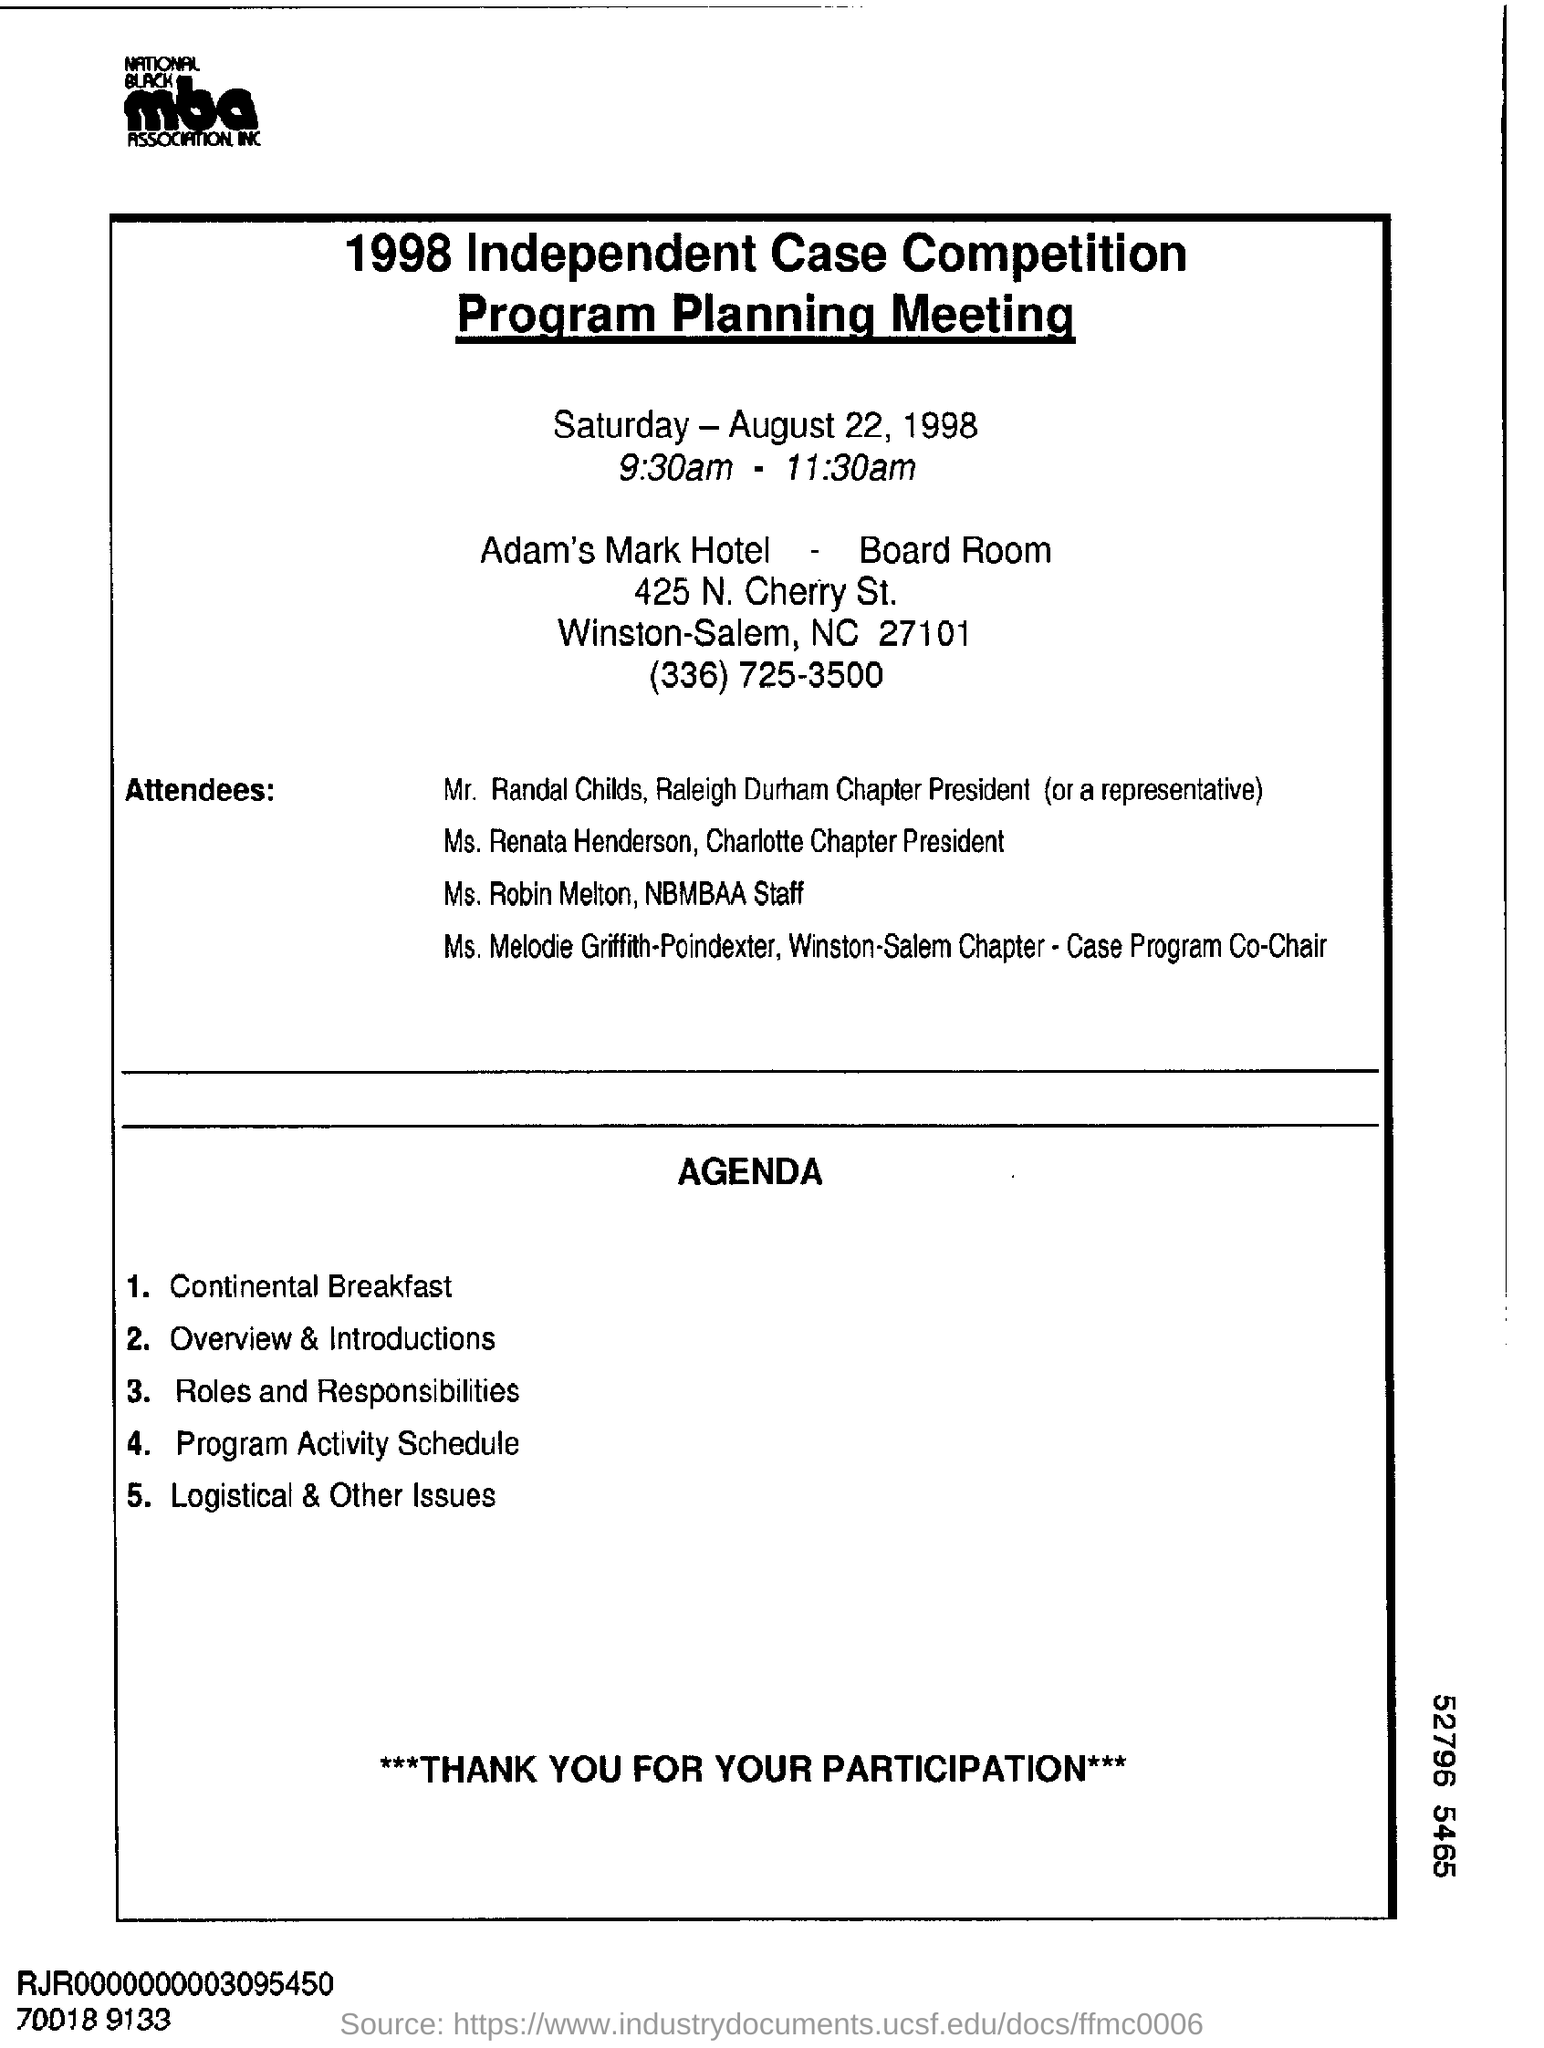When is the Program Planning Meeting conducted?
Make the answer very short. Saturday- august 22, 1998. At what time is the Program Planning Meeting  conducted?
Give a very brief answer. 9.30am - 11.30am. Who is Ms. Renata Henderson?
Your answer should be compact. Charlotte Chapter President. 